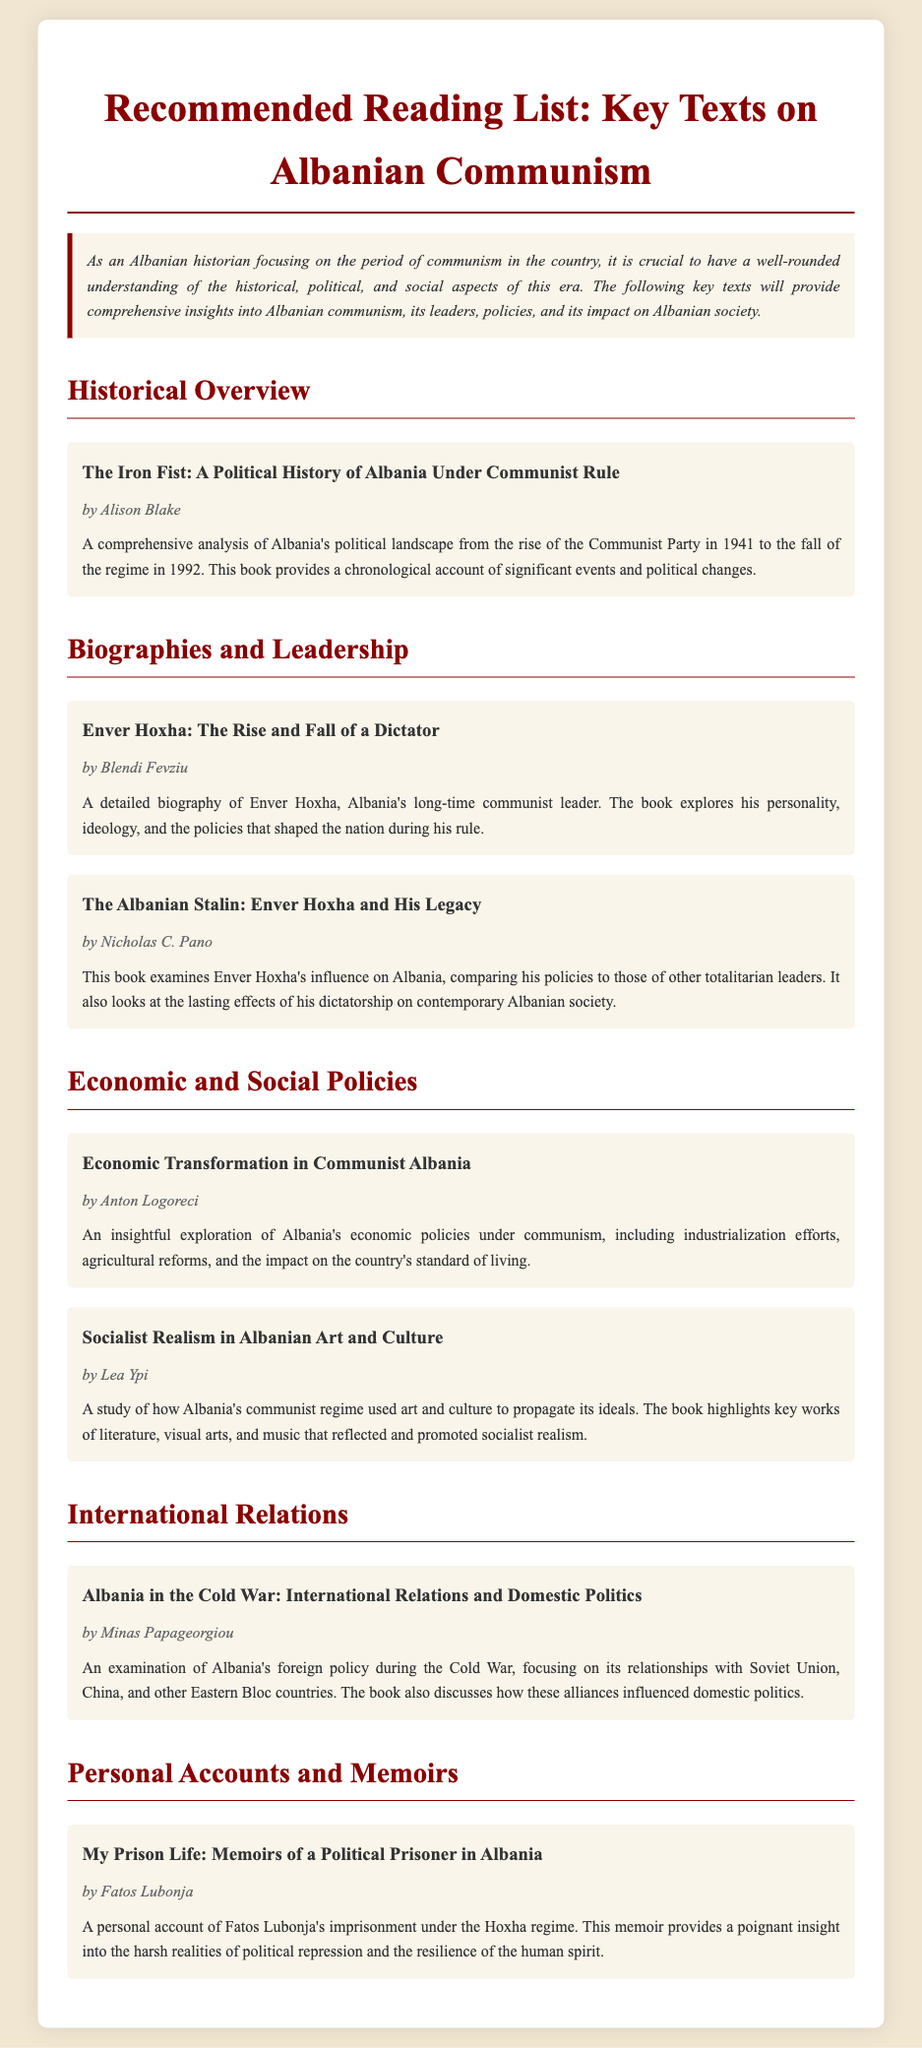what is the title of the first book listed? The first book listed in the document is "The Iron Fist: A Political History of Albania Under Communist Rule."
Answer: The Iron Fist: A Political History of Albania Under Communist Rule who is the author of "Enver Hoxha: The Rise and Fall of a Dictator"? The author of this biography is Blendi Fevziu.
Answer: Blendi Fevziu how many books are listed under Economic and Social Policies? There are two books listed under this section in the document.
Answer: 2 what year marks the end of the communist regime in Albania? The document mentions that the regime fell in 1992.
Answer: 1992 which book focuses on international relations during the Cold War? The book that examines this topic is "Albania in the Cold War: International Relations and Domestic Politics."
Answer: Albania in the Cold War: International Relations and Domestic Politics who wrote the memoir titled "My Prison Life"? The memoir is authored by Fatos Lubonja.
Answer: Fatos Lubonja what is a central theme of "Socialist Realism in Albanian Art and Culture"? The book studies how art and culture propagated the ideals of the communist regime.
Answer: Propagation of ideals how many sections are included in the recommended reading list? The document includes five distinct sections outlining various themes.
Answer: 5 